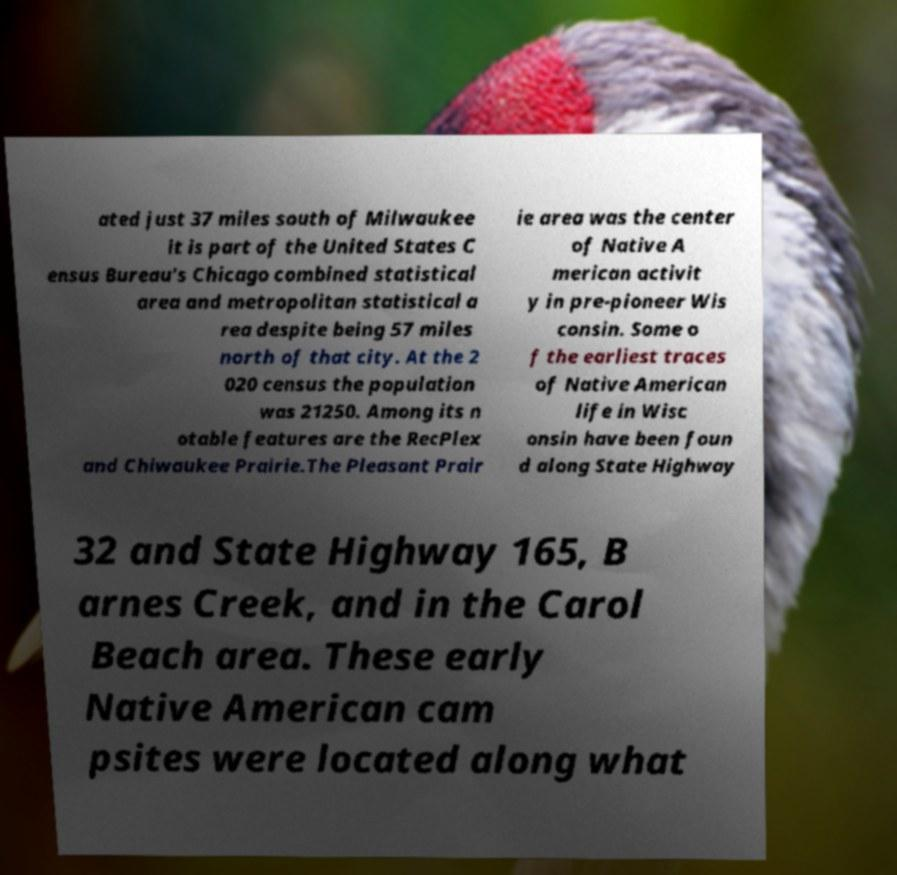Please read and relay the text visible in this image. What does it say? ated just 37 miles south of Milwaukee it is part of the United States C ensus Bureau's Chicago combined statistical area and metropolitan statistical a rea despite being 57 miles north of that city. At the 2 020 census the population was 21250. Among its n otable features are the RecPlex and Chiwaukee Prairie.The Pleasant Prair ie area was the center of Native A merican activit y in pre-pioneer Wis consin. Some o f the earliest traces of Native American life in Wisc onsin have been foun d along State Highway 32 and State Highway 165, B arnes Creek, and in the Carol Beach area. These early Native American cam psites were located along what 